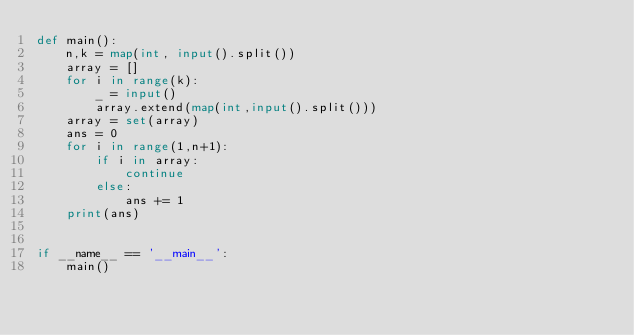<code> <loc_0><loc_0><loc_500><loc_500><_Python_>def main():
    n,k = map(int, input().split())
    array = []
    for i in range(k):
        _ = input()
        array.extend(map(int,input().split()))
    array = set(array)
    ans = 0
    for i in range(1,n+1):
        if i in array:
            continue
        else:
            ans += 1
    print(ans)


if __name__ == '__main__':
    main()
</code> 